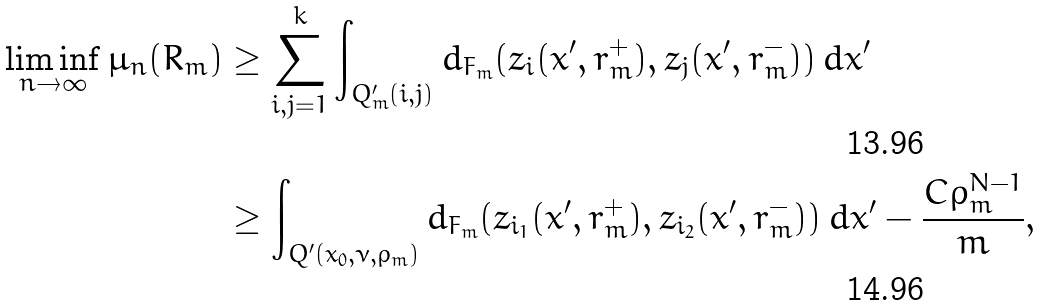Convert formula to latex. <formula><loc_0><loc_0><loc_500><loc_500>\liminf _ { n \to \infty } \mu _ { n } ( R _ { m } ) & \geq \sum _ { i , j = 1 } ^ { k } \int _ { Q ^ { \prime } _ { m } ( i , j ) } d _ { F _ { m } } ( z _ { i } ( x ^ { \prime } , r _ { m } ^ { + } ) , z _ { j } ( x ^ { \prime } , r _ { m } ^ { - } ) ) \, d x ^ { \prime } \\ & \geq \int _ { Q ^ { \prime } ( x _ { 0 } , \nu , \rho _ { m } ) } d _ { F _ { m } } ( z _ { i _ { 1 } } ( x ^ { \prime } , r _ { m } ^ { + } ) , z _ { i _ { 2 } } ( x ^ { \prime } , r _ { m } ^ { - } ) ) \, d x ^ { \prime } - \frac { C \rho _ { m } ^ { N - 1 } } { m } ,</formula> 